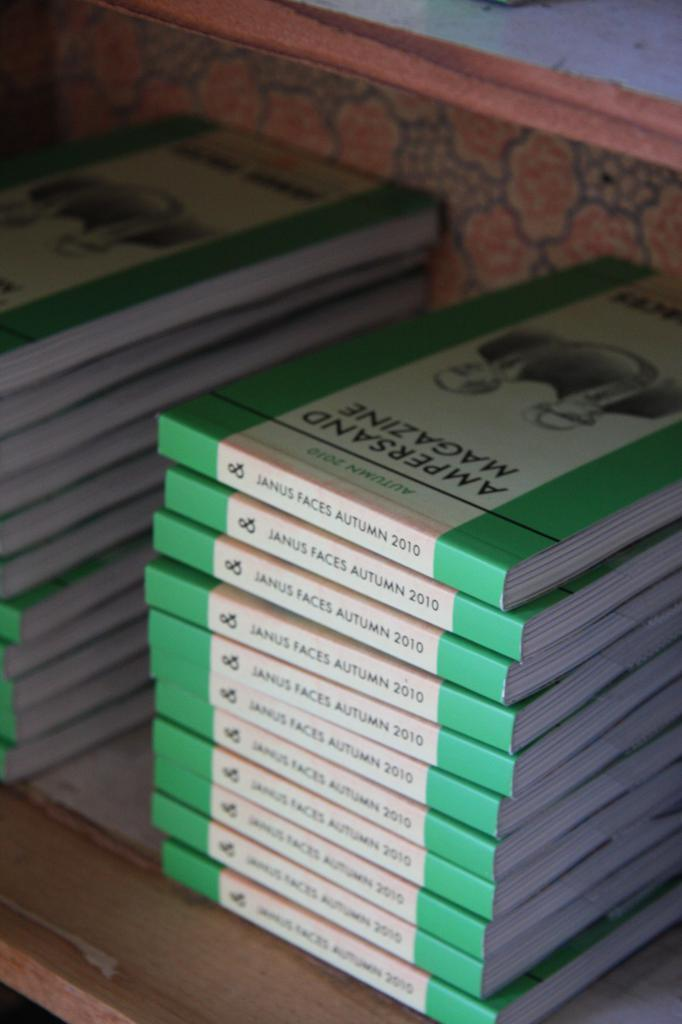<image>
Offer a succinct explanation of the picture presented. A stack of copies of Janus Faces Autumn 2010. 